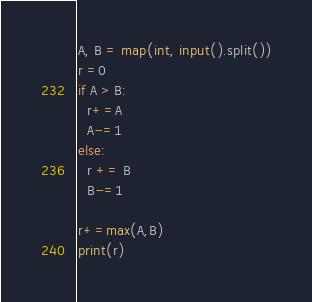Convert code to text. <code><loc_0><loc_0><loc_500><loc_500><_Python_>A, B = map(int, input().split())
r =0
if A > B:
  r+=A
  A-=1
else:
  r += B
  B-=1
 
r+=max(A,B)
print(r)</code> 